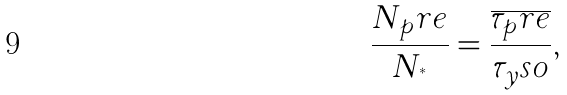<formula> <loc_0><loc_0><loc_500><loc_500>\frac { N _ { p } r e } { N _ { ^ { * } } } = \frac { \overline { \tau _ { p } r e } } { \tau _ { y } s o } ,</formula> 